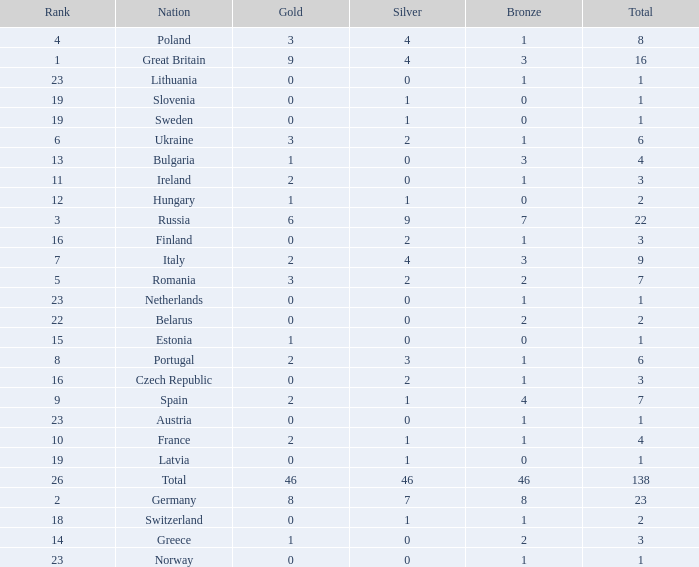What is the total number for a total when the nation is netherlands and silver is larger than 0? 0.0. Can you give me this table as a dict? {'header': ['Rank', 'Nation', 'Gold', 'Silver', 'Bronze', 'Total'], 'rows': [['4', 'Poland', '3', '4', '1', '8'], ['1', 'Great Britain', '9', '4', '3', '16'], ['23', 'Lithuania', '0', '0', '1', '1'], ['19', 'Slovenia', '0', '1', '0', '1'], ['19', 'Sweden', '0', '1', '0', '1'], ['6', 'Ukraine', '3', '2', '1', '6'], ['13', 'Bulgaria', '1', '0', '3', '4'], ['11', 'Ireland', '2', '0', '1', '3'], ['12', 'Hungary', '1', '1', '0', '2'], ['3', 'Russia', '6', '9', '7', '22'], ['16', 'Finland', '0', '2', '1', '3'], ['7', 'Italy', '2', '4', '3', '9'], ['5', 'Romania', '3', '2', '2', '7'], ['23', 'Netherlands', '0', '0', '1', '1'], ['22', 'Belarus', '0', '0', '2', '2'], ['15', 'Estonia', '1', '0', '0', '1'], ['8', 'Portugal', '2', '3', '1', '6'], ['16', 'Czech Republic', '0', '2', '1', '3'], ['9', 'Spain', '2', '1', '4', '7'], ['23', 'Austria', '0', '0', '1', '1'], ['10', 'France', '2', '1', '1', '4'], ['19', 'Latvia', '0', '1', '0', '1'], ['26', 'Total', '46', '46', '46', '138'], ['2', 'Germany', '8', '7', '8', '23'], ['18', 'Switzerland', '0', '1', '1', '2'], ['14', 'Greece', '1', '0', '2', '3'], ['23', 'Norway', '0', '0', '1', '1']]} 